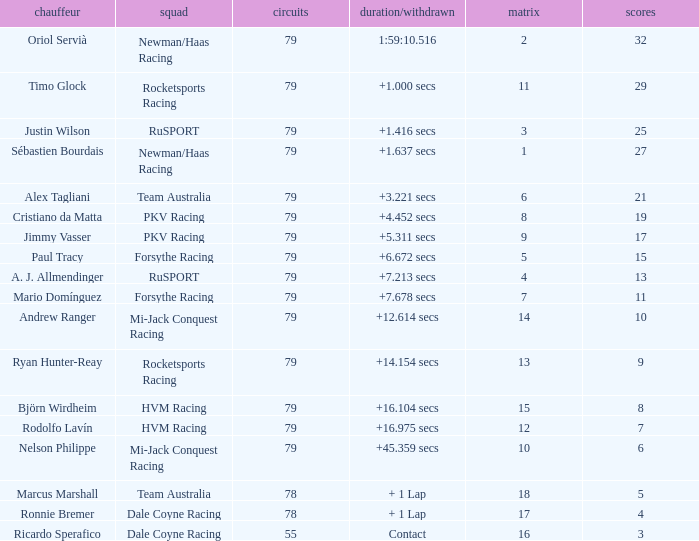What grid has 78 laps, and Ronnie Bremer as driver? 17.0. 